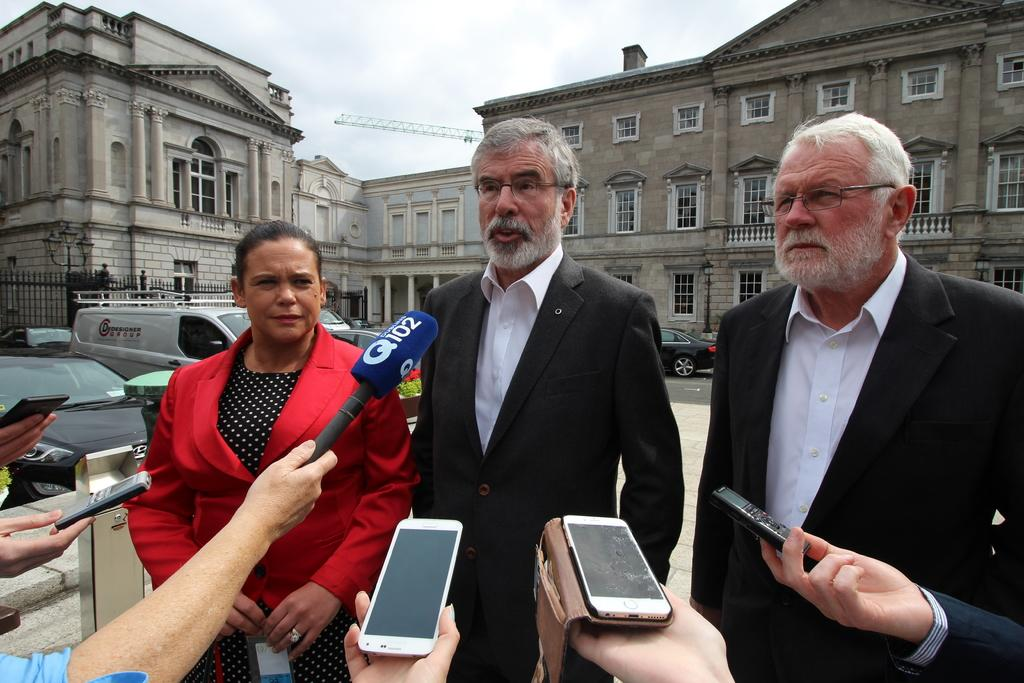<image>
Provide a brief description of the given image. someone from Q102, along with others listening and recording gentleman and two others 